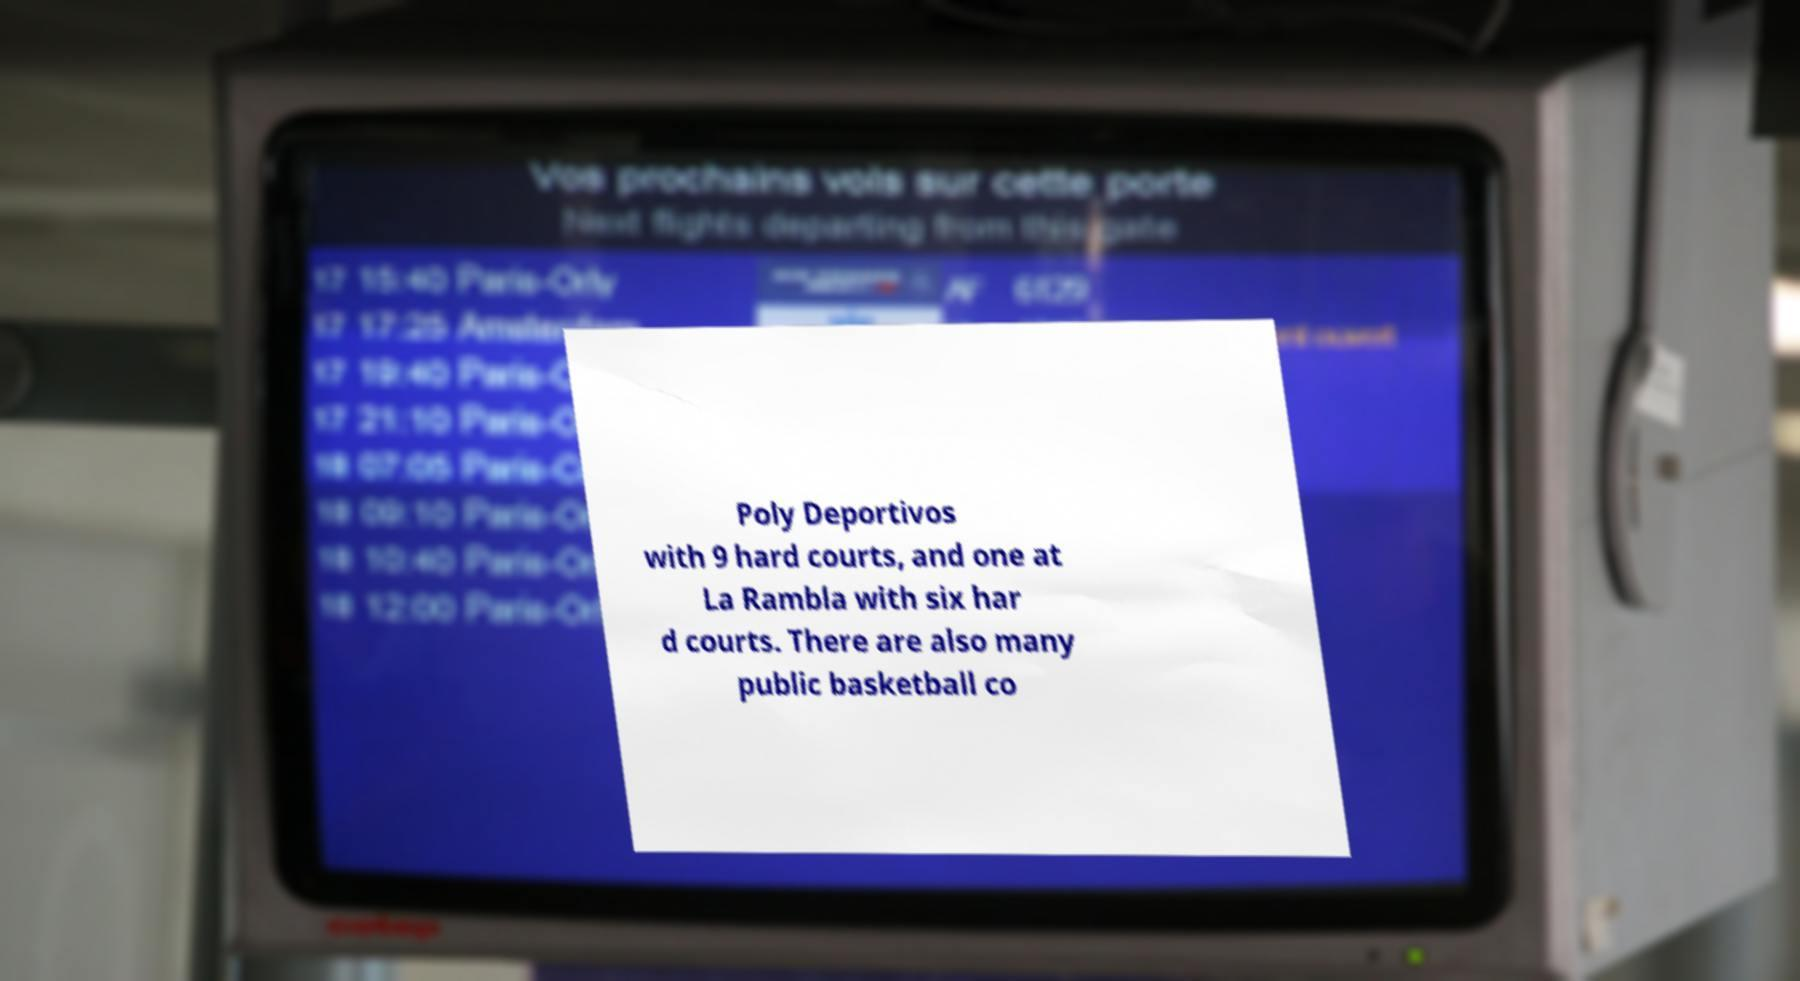There's text embedded in this image that I need extracted. Can you transcribe it verbatim? Poly Deportivos with 9 hard courts, and one at La Rambla with six har d courts. There are also many public basketball co 